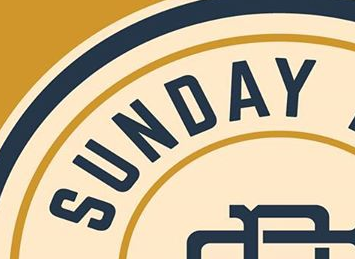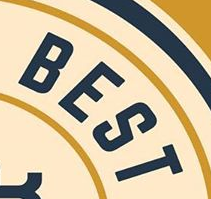Read the text content from these images in order, separated by a semicolon. SUNDAY; BEST 